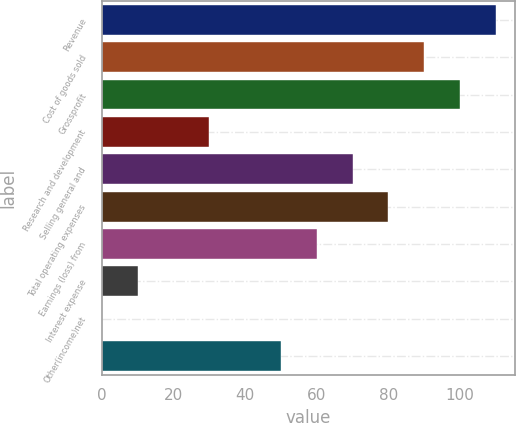Convert chart. <chart><loc_0><loc_0><loc_500><loc_500><bar_chart><fcel>Revenue<fcel>Cost of goods sold<fcel>Grossprofit<fcel>Research and development<fcel>Selling general and<fcel>Total operating expenses<fcel>Earnings (loss) from<fcel>Interest expense<fcel>Other(income)net<fcel>Unnamed: 9<nl><fcel>109.99<fcel>90.01<fcel>100<fcel>30.07<fcel>70.03<fcel>80.02<fcel>60.04<fcel>10.09<fcel>0.1<fcel>50.05<nl></chart> 